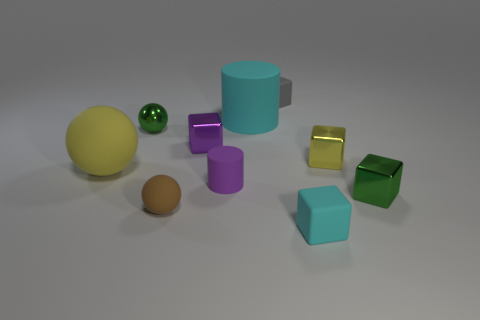What number of yellow objects are either tiny matte blocks or large matte spheres?
Your response must be concise. 1. How many brown shiny cubes are the same size as the yellow metallic object?
Give a very brief answer. 0. There is a small rubber thing that is in front of the purple matte thing and on the right side of the purple metal cube; what color is it?
Keep it short and to the point. Cyan. Are there more cyan rubber things that are in front of the tiny matte cylinder than tiny brown balls?
Your answer should be very brief. No. Are any large rubber cylinders visible?
Give a very brief answer. Yes. Is the big matte cylinder the same color as the big rubber ball?
Provide a short and direct response. No. What number of large things are either blue rubber spheres or yellow balls?
Your answer should be compact. 1. Is there anything else that is the same color as the tiny metallic ball?
Your answer should be compact. Yes. The tiny purple thing that is the same material as the yellow sphere is what shape?
Give a very brief answer. Cylinder. There is a cyan thing behind the tiny yellow metal thing; what size is it?
Offer a very short reply. Large. 